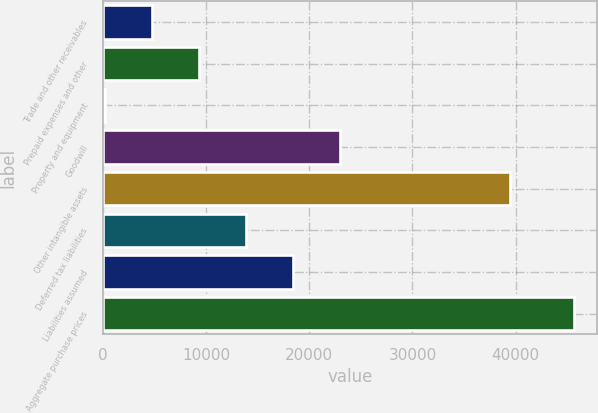Convert chart to OTSL. <chart><loc_0><loc_0><loc_500><loc_500><bar_chart><fcel>Trade and other receivables<fcel>Prepaid expenses and other<fcel>Property and equipment<fcel>Goodwill<fcel>Other intangible assets<fcel>Deferred tax liabilities<fcel>Liabilities assumed<fcel>Aggregate purchase prices<nl><fcel>4748.7<fcel>9294.4<fcel>203<fcel>22931.5<fcel>39433<fcel>13840.1<fcel>18385.8<fcel>45660<nl></chart> 